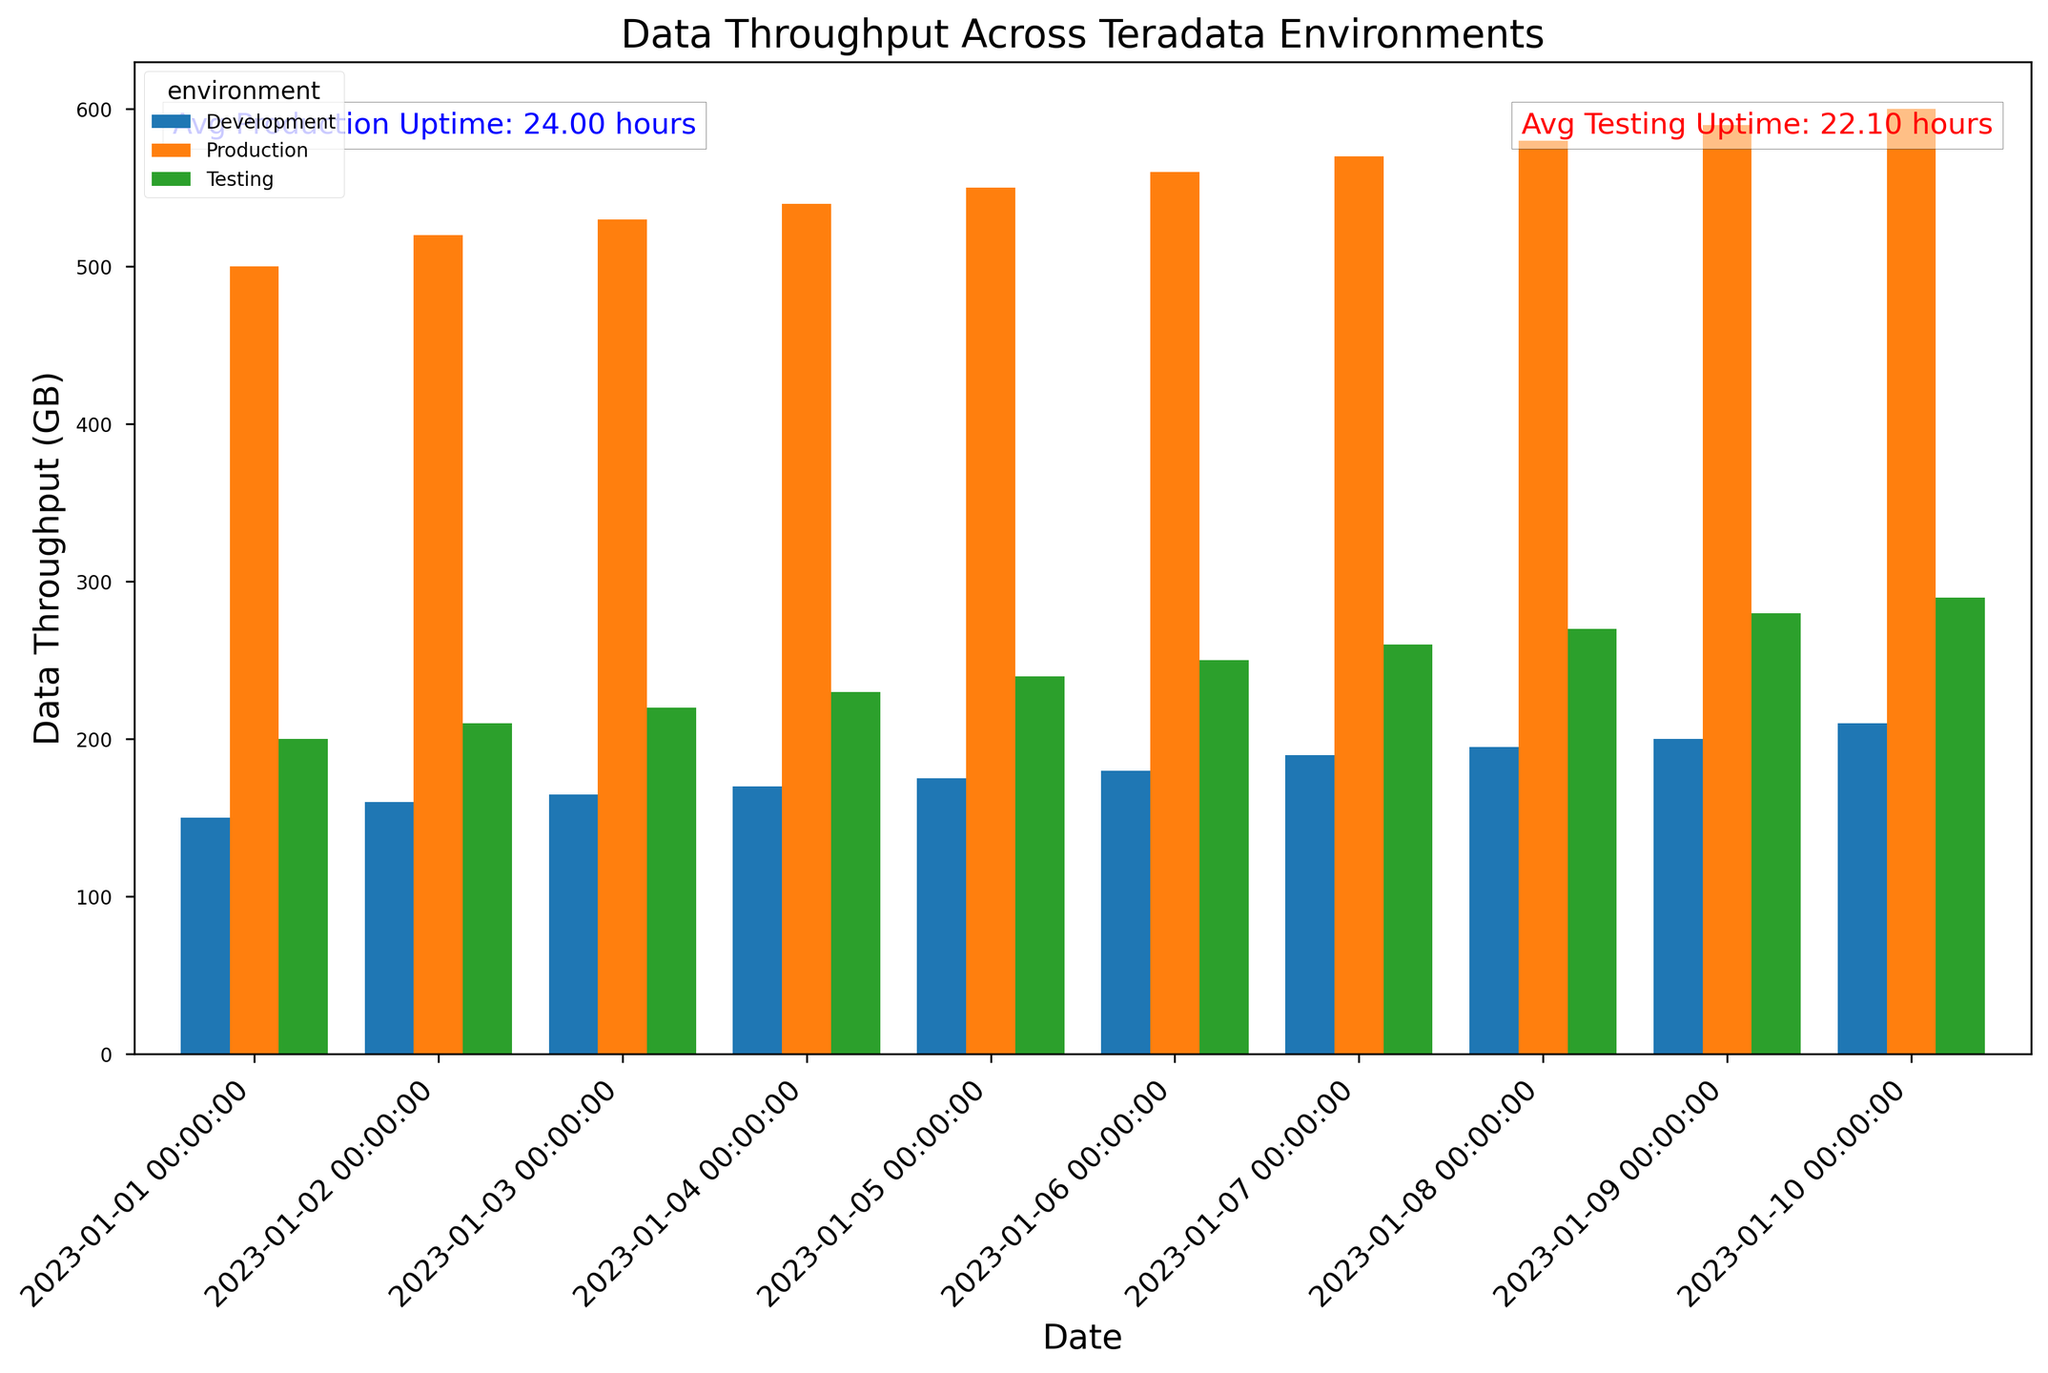Which environment has the highest data throughput on 2023-01-01? Compare the heights of the bars on 2023-01-01. The highest bar represents the Production environment with 500 GB data throughput.
Answer: Production What is the average server uptime for the Production environment? The figure has an annotation specifying the average server uptime for the Production environment. According to the annotation, the average is 24 hours.
Answer: 24 hours How much more data was processed in the Production environment compared to the Development environment on 2023-01-05? Look at the bars for 2023-01-05. The Production environment bar reaches 550 GB, and the Development environment bar reaches 175 GB. The difference is 550 - 175 = 375 GB.
Answer: 375 GB On which date did the Production environment first surpass 550 GB of data throughput? Examine the dates on the x-axis and find when the Production environment's bar first exceeds 550 GB. This occurs on 2023-01-06.
Answer: 2023-01-06 Is the data throughput generally increasing or decreasing over time in the Testing environment? Observe the trend of the bars for the Testing environment from left to right. The bars are progressively getting taller, indicating an increasing trend.
Answer: Increasing Which date shows the least data throughput for the Development environment? Check the height of the bars for the Development environment. The shortest bar is on 2023-01-01 with 150 GB.
Answer: 2023-01-01 How does the average server uptime of the Testing environment compare to the Production environment? Reference the text annotations. The Testing environment's average uptime is 22.45 hours, while Production has 24 hours. 22.45 is less than 24.
Answer: Less What is the total data throughput for the Production environment over all dates? Sum the heights of the bars representing the Production environment. 500 + 520 + 530 + 540 + 550 + 560 + 570 + 580 + 590 + 600 = 5540 GB
Answer: 5540 GB Which environment had the closest data throughput value on 2023-01-10? Comparing Production (600 GB), Development (210 GB), and Testing (290 GB), the Testing environment at 290 GB is closest to the Development environment's 210 GB.
Answer: Testing 